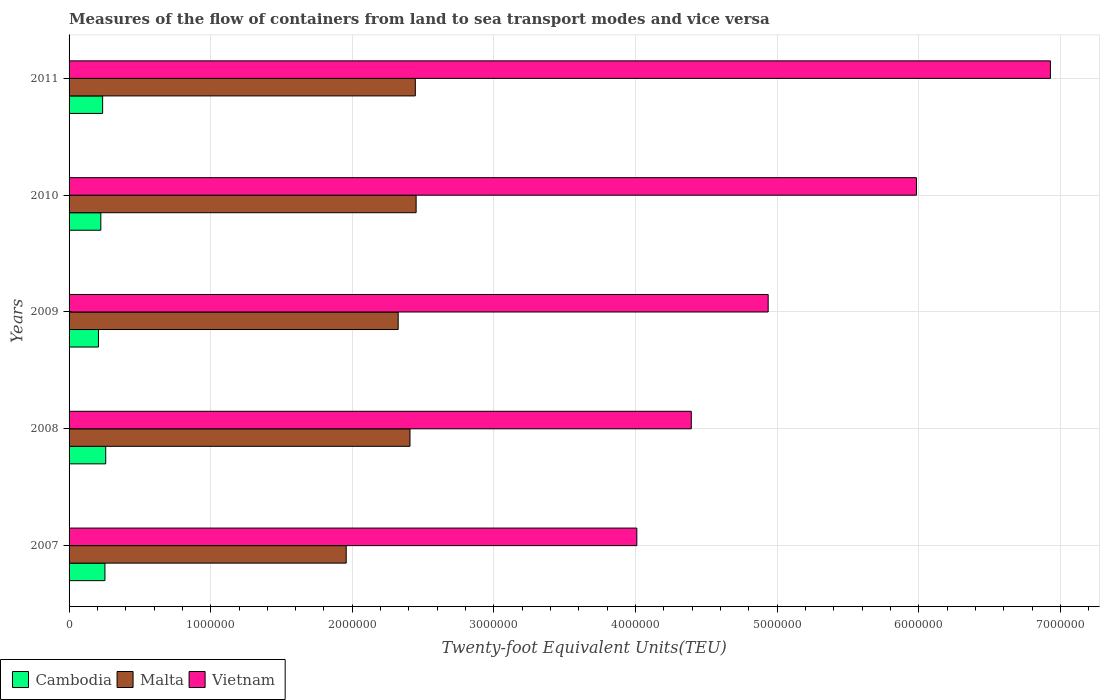How many different coloured bars are there?
Your answer should be very brief. 3. Are the number of bars per tick equal to the number of legend labels?
Keep it short and to the point. Yes. In how many cases, is the number of bars for a given year not equal to the number of legend labels?
Keep it short and to the point. 0. What is the container port traffic in Cambodia in 2008?
Provide a succinct answer. 2.59e+05. Across all years, what is the maximum container port traffic in Malta?
Offer a very short reply. 2.45e+06. Across all years, what is the minimum container port traffic in Cambodia?
Offer a terse response. 2.08e+05. In which year was the container port traffic in Cambodia maximum?
Your answer should be compact. 2008. In which year was the container port traffic in Vietnam minimum?
Offer a very short reply. 2007. What is the total container port traffic in Malta in the graph?
Keep it short and to the point. 1.16e+07. What is the difference between the container port traffic in Cambodia in 2008 and that in 2009?
Ensure brevity in your answer.  5.12e+04. What is the difference between the container port traffic in Cambodia in 2011 and the container port traffic in Vietnam in 2007?
Your answer should be compact. -3.77e+06. What is the average container port traffic in Vietnam per year?
Your response must be concise. 5.25e+06. In the year 2009, what is the difference between the container port traffic in Cambodia and container port traffic in Malta?
Offer a very short reply. -2.12e+06. What is the ratio of the container port traffic in Vietnam in 2010 to that in 2011?
Keep it short and to the point. 0.86. Is the container port traffic in Cambodia in 2008 less than that in 2009?
Your answer should be compact. No. What is the difference between the highest and the second highest container port traffic in Malta?
Your answer should be compact. 5683.65. What is the difference between the highest and the lowest container port traffic in Cambodia?
Offer a very short reply. 5.12e+04. In how many years, is the container port traffic in Malta greater than the average container port traffic in Malta taken over all years?
Make the answer very short. 4. What does the 2nd bar from the top in 2007 represents?
Keep it short and to the point. Malta. What does the 1st bar from the bottom in 2009 represents?
Your answer should be compact. Cambodia. How many bars are there?
Your answer should be very brief. 15. Are all the bars in the graph horizontal?
Ensure brevity in your answer.  Yes. Are the values on the major ticks of X-axis written in scientific E-notation?
Provide a short and direct response. No. Does the graph contain any zero values?
Ensure brevity in your answer.  No. Does the graph contain grids?
Ensure brevity in your answer.  Yes. Where does the legend appear in the graph?
Your answer should be compact. Bottom left. How many legend labels are there?
Your answer should be very brief. 3. What is the title of the graph?
Your answer should be very brief. Measures of the flow of containers from land to sea transport modes and vice versa. What is the label or title of the X-axis?
Keep it short and to the point. Twenty-foot Equivalent Units(TEU). What is the label or title of the Y-axis?
Provide a short and direct response. Years. What is the Twenty-foot Equivalent Units(TEU) of Cambodia in 2007?
Make the answer very short. 2.53e+05. What is the Twenty-foot Equivalent Units(TEU) in Malta in 2007?
Your response must be concise. 1.96e+06. What is the Twenty-foot Equivalent Units(TEU) in Vietnam in 2007?
Your answer should be very brief. 4.01e+06. What is the Twenty-foot Equivalent Units(TEU) of Cambodia in 2008?
Provide a short and direct response. 2.59e+05. What is the Twenty-foot Equivalent Units(TEU) of Malta in 2008?
Offer a very short reply. 2.41e+06. What is the Twenty-foot Equivalent Units(TEU) in Vietnam in 2008?
Offer a terse response. 4.39e+06. What is the Twenty-foot Equivalent Units(TEU) in Cambodia in 2009?
Offer a very short reply. 2.08e+05. What is the Twenty-foot Equivalent Units(TEU) in Malta in 2009?
Your response must be concise. 2.32e+06. What is the Twenty-foot Equivalent Units(TEU) in Vietnam in 2009?
Provide a succinct answer. 4.94e+06. What is the Twenty-foot Equivalent Units(TEU) in Cambodia in 2010?
Make the answer very short. 2.24e+05. What is the Twenty-foot Equivalent Units(TEU) in Malta in 2010?
Make the answer very short. 2.45e+06. What is the Twenty-foot Equivalent Units(TEU) in Vietnam in 2010?
Offer a very short reply. 5.98e+06. What is the Twenty-foot Equivalent Units(TEU) of Cambodia in 2011?
Provide a succinct answer. 2.37e+05. What is the Twenty-foot Equivalent Units(TEU) in Malta in 2011?
Your response must be concise. 2.44e+06. What is the Twenty-foot Equivalent Units(TEU) in Vietnam in 2011?
Provide a succinct answer. 6.93e+06. Across all years, what is the maximum Twenty-foot Equivalent Units(TEU) in Cambodia?
Give a very brief answer. 2.59e+05. Across all years, what is the maximum Twenty-foot Equivalent Units(TEU) of Malta?
Make the answer very short. 2.45e+06. Across all years, what is the maximum Twenty-foot Equivalent Units(TEU) of Vietnam?
Your answer should be very brief. 6.93e+06. Across all years, what is the minimum Twenty-foot Equivalent Units(TEU) of Cambodia?
Offer a very short reply. 2.08e+05. Across all years, what is the minimum Twenty-foot Equivalent Units(TEU) in Malta?
Keep it short and to the point. 1.96e+06. Across all years, what is the minimum Twenty-foot Equivalent Units(TEU) of Vietnam?
Your answer should be compact. 4.01e+06. What is the total Twenty-foot Equivalent Units(TEU) in Cambodia in the graph?
Offer a very short reply. 1.18e+06. What is the total Twenty-foot Equivalent Units(TEU) in Malta in the graph?
Your answer should be compact. 1.16e+07. What is the total Twenty-foot Equivalent Units(TEU) of Vietnam in the graph?
Offer a very short reply. 2.63e+07. What is the difference between the Twenty-foot Equivalent Units(TEU) of Cambodia in 2007 and that in 2008?
Offer a very short reply. -5504. What is the difference between the Twenty-foot Equivalent Units(TEU) of Malta in 2007 and that in 2008?
Your answer should be compact. -4.50e+05. What is the difference between the Twenty-foot Equivalent Units(TEU) of Vietnam in 2007 and that in 2008?
Offer a terse response. -3.85e+05. What is the difference between the Twenty-foot Equivalent Units(TEU) of Cambodia in 2007 and that in 2009?
Ensure brevity in your answer.  4.57e+04. What is the difference between the Twenty-foot Equivalent Units(TEU) of Malta in 2007 and that in 2009?
Give a very brief answer. -3.67e+05. What is the difference between the Twenty-foot Equivalent Units(TEU) of Vietnam in 2007 and that in 2009?
Give a very brief answer. -9.28e+05. What is the difference between the Twenty-foot Equivalent Units(TEU) in Cambodia in 2007 and that in 2010?
Keep it short and to the point. 2.91e+04. What is the difference between the Twenty-foot Equivalent Units(TEU) in Malta in 2007 and that in 2010?
Offer a terse response. -4.94e+05. What is the difference between the Twenty-foot Equivalent Units(TEU) of Vietnam in 2007 and that in 2010?
Provide a short and direct response. -1.97e+06. What is the difference between the Twenty-foot Equivalent Units(TEU) of Cambodia in 2007 and that in 2011?
Make the answer very short. 1.63e+04. What is the difference between the Twenty-foot Equivalent Units(TEU) in Malta in 2007 and that in 2011?
Keep it short and to the point. -4.88e+05. What is the difference between the Twenty-foot Equivalent Units(TEU) in Vietnam in 2007 and that in 2011?
Ensure brevity in your answer.  -2.92e+06. What is the difference between the Twenty-foot Equivalent Units(TEU) of Cambodia in 2008 and that in 2009?
Provide a succinct answer. 5.12e+04. What is the difference between the Twenty-foot Equivalent Units(TEU) of Malta in 2008 and that in 2009?
Provide a succinct answer. 8.34e+04. What is the difference between the Twenty-foot Equivalent Units(TEU) of Vietnam in 2008 and that in 2009?
Make the answer very short. -5.43e+05. What is the difference between the Twenty-foot Equivalent Units(TEU) of Cambodia in 2008 and that in 2010?
Provide a succinct answer. 3.46e+04. What is the difference between the Twenty-foot Equivalent Units(TEU) in Malta in 2008 and that in 2010?
Provide a succinct answer. -4.33e+04. What is the difference between the Twenty-foot Equivalent Units(TEU) in Vietnam in 2008 and that in 2010?
Your response must be concise. -1.59e+06. What is the difference between the Twenty-foot Equivalent Units(TEU) of Cambodia in 2008 and that in 2011?
Your response must be concise. 2.18e+04. What is the difference between the Twenty-foot Equivalent Units(TEU) of Malta in 2008 and that in 2011?
Provide a succinct answer. -3.76e+04. What is the difference between the Twenty-foot Equivalent Units(TEU) in Vietnam in 2008 and that in 2011?
Provide a short and direct response. -2.54e+06. What is the difference between the Twenty-foot Equivalent Units(TEU) in Cambodia in 2009 and that in 2010?
Offer a terse response. -1.66e+04. What is the difference between the Twenty-foot Equivalent Units(TEU) of Malta in 2009 and that in 2010?
Provide a short and direct response. -1.27e+05. What is the difference between the Twenty-foot Equivalent Units(TEU) of Vietnam in 2009 and that in 2010?
Your answer should be very brief. -1.05e+06. What is the difference between the Twenty-foot Equivalent Units(TEU) of Cambodia in 2009 and that in 2011?
Your response must be concise. -2.94e+04. What is the difference between the Twenty-foot Equivalent Units(TEU) of Malta in 2009 and that in 2011?
Keep it short and to the point. -1.21e+05. What is the difference between the Twenty-foot Equivalent Units(TEU) of Vietnam in 2009 and that in 2011?
Your answer should be compact. -1.99e+06. What is the difference between the Twenty-foot Equivalent Units(TEU) in Cambodia in 2010 and that in 2011?
Give a very brief answer. -1.28e+04. What is the difference between the Twenty-foot Equivalent Units(TEU) of Malta in 2010 and that in 2011?
Give a very brief answer. 5683.65. What is the difference between the Twenty-foot Equivalent Units(TEU) of Vietnam in 2010 and that in 2011?
Give a very brief answer. -9.46e+05. What is the difference between the Twenty-foot Equivalent Units(TEU) of Cambodia in 2007 and the Twenty-foot Equivalent Units(TEU) of Malta in 2008?
Make the answer very short. -2.15e+06. What is the difference between the Twenty-foot Equivalent Units(TEU) in Cambodia in 2007 and the Twenty-foot Equivalent Units(TEU) in Vietnam in 2008?
Make the answer very short. -4.14e+06. What is the difference between the Twenty-foot Equivalent Units(TEU) in Malta in 2007 and the Twenty-foot Equivalent Units(TEU) in Vietnam in 2008?
Your response must be concise. -2.44e+06. What is the difference between the Twenty-foot Equivalent Units(TEU) of Cambodia in 2007 and the Twenty-foot Equivalent Units(TEU) of Malta in 2009?
Your answer should be very brief. -2.07e+06. What is the difference between the Twenty-foot Equivalent Units(TEU) in Cambodia in 2007 and the Twenty-foot Equivalent Units(TEU) in Vietnam in 2009?
Your answer should be compact. -4.68e+06. What is the difference between the Twenty-foot Equivalent Units(TEU) in Malta in 2007 and the Twenty-foot Equivalent Units(TEU) in Vietnam in 2009?
Keep it short and to the point. -2.98e+06. What is the difference between the Twenty-foot Equivalent Units(TEU) of Cambodia in 2007 and the Twenty-foot Equivalent Units(TEU) of Malta in 2010?
Make the answer very short. -2.20e+06. What is the difference between the Twenty-foot Equivalent Units(TEU) of Cambodia in 2007 and the Twenty-foot Equivalent Units(TEU) of Vietnam in 2010?
Make the answer very short. -5.73e+06. What is the difference between the Twenty-foot Equivalent Units(TEU) in Malta in 2007 and the Twenty-foot Equivalent Units(TEU) in Vietnam in 2010?
Provide a short and direct response. -4.03e+06. What is the difference between the Twenty-foot Equivalent Units(TEU) in Cambodia in 2007 and the Twenty-foot Equivalent Units(TEU) in Malta in 2011?
Your answer should be compact. -2.19e+06. What is the difference between the Twenty-foot Equivalent Units(TEU) in Cambodia in 2007 and the Twenty-foot Equivalent Units(TEU) in Vietnam in 2011?
Provide a succinct answer. -6.68e+06. What is the difference between the Twenty-foot Equivalent Units(TEU) of Malta in 2007 and the Twenty-foot Equivalent Units(TEU) of Vietnam in 2011?
Make the answer very short. -4.97e+06. What is the difference between the Twenty-foot Equivalent Units(TEU) of Cambodia in 2008 and the Twenty-foot Equivalent Units(TEU) of Malta in 2009?
Offer a very short reply. -2.07e+06. What is the difference between the Twenty-foot Equivalent Units(TEU) of Cambodia in 2008 and the Twenty-foot Equivalent Units(TEU) of Vietnam in 2009?
Provide a succinct answer. -4.68e+06. What is the difference between the Twenty-foot Equivalent Units(TEU) in Malta in 2008 and the Twenty-foot Equivalent Units(TEU) in Vietnam in 2009?
Make the answer very short. -2.53e+06. What is the difference between the Twenty-foot Equivalent Units(TEU) in Cambodia in 2008 and the Twenty-foot Equivalent Units(TEU) in Malta in 2010?
Offer a terse response. -2.19e+06. What is the difference between the Twenty-foot Equivalent Units(TEU) in Cambodia in 2008 and the Twenty-foot Equivalent Units(TEU) in Vietnam in 2010?
Your response must be concise. -5.72e+06. What is the difference between the Twenty-foot Equivalent Units(TEU) in Malta in 2008 and the Twenty-foot Equivalent Units(TEU) in Vietnam in 2010?
Offer a very short reply. -3.58e+06. What is the difference between the Twenty-foot Equivalent Units(TEU) of Cambodia in 2008 and the Twenty-foot Equivalent Units(TEU) of Malta in 2011?
Offer a terse response. -2.19e+06. What is the difference between the Twenty-foot Equivalent Units(TEU) of Cambodia in 2008 and the Twenty-foot Equivalent Units(TEU) of Vietnam in 2011?
Offer a very short reply. -6.67e+06. What is the difference between the Twenty-foot Equivalent Units(TEU) in Malta in 2008 and the Twenty-foot Equivalent Units(TEU) in Vietnam in 2011?
Your answer should be very brief. -4.52e+06. What is the difference between the Twenty-foot Equivalent Units(TEU) of Cambodia in 2009 and the Twenty-foot Equivalent Units(TEU) of Malta in 2010?
Your answer should be very brief. -2.24e+06. What is the difference between the Twenty-foot Equivalent Units(TEU) in Cambodia in 2009 and the Twenty-foot Equivalent Units(TEU) in Vietnam in 2010?
Your answer should be very brief. -5.78e+06. What is the difference between the Twenty-foot Equivalent Units(TEU) of Malta in 2009 and the Twenty-foot Equivalent Units(TEU) of Vietnam in 2010?
Your answer should be very brief. -3.66e+06. What is the difference between the Twenty-foot Equivalent Units(TEU) in Cambodia in 2009 and the Twenty-foot Equivalent Units(TEU) in Malta in 2011?
Your answer should be compact. -2.24e+06. What is the difference between the Twenty-foot Equivalent Units(TEU) of Cambodia in 2009 and the Twenty-foot Equivalent Units(TEU) of Vietnam in 2011?
Provide a succinct answer. -6.72e+06. What is the difference between the Twenty-foot Equivalent Units(TEU) in Malta in 2009 and the Twenty-foot Equivalent Units(TEU) in Vietnam in 2011?
Provide a short and direct response. -4.61e+06. What is the difference between the Twenty-foot Equivalent Units(TEU) of Cambodia in 2010 and the Twenty-foot Equivalent Units(TEU) of Malta in 2011?
Keep it short and to the point. -2.22e+06. What is the difference between the Twenty-foot Equivalent Units(TEU) in Cambodia in 2010 and the Twenty-foot Equivalent Units(TEU) in Vietnam in 2011?
Provide a succinct answer. -6.71e+06. What is the difference between the Twenty-foot Equivalent Units(TEU) of Malta in 2010 and the Twenty-foot Equivalent Units(TEU) of Vietnam in 2011?
Give a very brief answer. -4.48e+06. What is the average Twenty-foot Equivalent Units(TEU) of Cambodia per year?
Make the answer very short. 2.36e+05. What is the average Twenty-foot Equivalent Units(TEU) in Malta per year?
Provide a succinct answer. 2.32e+06. What is the average Twenty-foot Equivalent Units(TEU) in Vietnam per year?
Offer a terse response. 5.25e+06. In the year 2007, what is the difference between the Twenty-foot Equivalent Units(TEU) of Cambodia and Twenty-foot Equivalent Units(TEU) of Malta?
Offer a terse response. -1.70e+06. In the year 2007, what is the difference between the Twenty-foot Equivalent Units(TEU) of Cambodia and Twenty-foot Equivalent Units(TEU) of Vietnam?
Ensure brevity in your answer.  -3.76e+06. In the year 2007, what is the difference between the Twenty-foot Equivalent Units(TEU) in Malta and Twenty-foot Equivalent Units(TEU) in Vietnam?
Offer a very short reply. -2.05e+06. In the year 2008, what is the difference between the Twenty-foot Equivalent Units(TEU) of Cambodia and Twenty-foot Equivalent Units(TEU) of Malta?
Make the answer very short. -2.15e+06. In the year 2008, what is the difference between the Twenty-foot Equivalent Units(TEU) of Cambodia and Twenty-foot Equivalent Units(TEU) of Vietnam?
Provide a short and direct response. -4.13e+06. In the year 2008, what is the difference between the Twenty-foot Equivalent Units(TEU) in Malta and Twenty-foot Equivalent Units(TEU) in Vietnam?
Provide a succinct answer. -1.99e+06. In the year 2009, what is the difference between the Twenty-foot Equivalent Units(TEU) in Cambodia and Twenty-foot Equivalent Units(TEU) in Malta?
Provide a short and direct response. -2.12e+06. In the year 2009, what is the difference between the Twenty-foot Equivalent Units(TEU) of Cambodia and Twenty-foot Equivalent Units(TEU) of Vietnam?
Provide a succinct answer. -4.73e+06. In the year 2009, what is the difference between the Twenty-foot Equivalent Units(TEU) in Malta and Twenty-foot Equivalent Units(TEU) in Vietnam?
Your answer should be very brief. -2.61e+06. In the year 2010, what is the difference between the Twenty-foot Equivalent Units(TEU) in Cambodia and Twenty-foot Equivalent Units(TEU) in Malta?
Ensure brevity in your answer.  -2.23e+06. In the year 2010, what is the difference between the Twenty-foot Equivalent Units(TEU) in Cambodia and Twenty-foot Equivalent Units(TEU) in Vietnam?
Keep it short and to the point. -5.76e+06. In the year 2010, what is the difference between the Twenty-foot Equivalent Units(TEU) in Malta and Twenty-foot Equivalent Units(TEU) in Vietnam?
Ensure brevity in your answer.  -3.53e+06. In the year 2011, what is the difference between the Twenty-foot Equivalent Units(TEU) in Cambodia and Twenty-foot Equivalent Units(TEU) in Malta?
Offer a very short reply. -2.21e+06. In the year 2011, what is the difference between the Twenty-foot Equivalent Units(TEU) in Cambodia and Twenty-foot Equivalent Units(TEU) in Vietnam?
Give a very brief answer. -6.69e+06. In the year 2011, what is the difference between the Twenty-foot Equivalent Units(TEU) of Malta and Twenty-foot Equivalent Units(TEU) of Vietnam?
Your answer should be very brief. -4.48e+06. What is the ratio of the Twenty-foot Equivalent Units(TEU) of Cambodia in 2007 to that in 2008?
Offer a very short reply. 0.98. What is the ratio of the Twenty-foot Equivalent Units(TEU) in Malta in 2007 to that in 2008?
Make the answer very short. 0.81. What is the ratio of the Twenty-foot Equivalent Units(TEU) of Vietnam in 2007 to that in 2008?
Offer a very short reply. 0.91. What is the ratio of the Twenty-foot Equivalent Units(TEU) in Cambodia in 2007 to that in 2009?
Offer a terse response. 1.22. What is the ratio of the Twenty-foot Equivalent Units(TEU) of Malta in 2007 to that in 2009?
Your answer should be very brief. 0.84. What is the ratio of the Twenty-foot Equivalent Units(TEU) of Vietnam in 2007 to that in 2009?
Provide a succinct answer. 0.81. What is the ratio of the Twenty-foot Equivalent Units(TEU) in Cambodia in 2007 to that in 2010?
Make the answer very short. 1.13. What is the ratio of the Twenty-foot Equivalent Units(TEU) of Malta in 2007 to that in 2010?
Give a very brief answer. 0.8. What is the ratio of the Twenty-foot Equivalent Units(TEU) in Vietnam in 2007 to that in 2010?
Give a very brief answer. 0.67. What is the ratio of the Twenty-foot Equivalent Units(TEU) of Cambodia in 2007 to that in 2011?
Your response must be concise. 1.07. What is the ratio of the Twenty-foot Equivalent Units(TEU) of Malta in 2007 to that in 2011?
Make the answer very short. 0.8. What is the ratio of the Twenty-foot Equivalent Units(TEU) in Vietnam in 2007 to that in 2011?
Give a very brief answer. 0.58. What is the ratio of the Twenty-foot Equivalent Units(TEU) in Cambodia in 2008 to that in 2009?
Your response must be concise. 1.25. What is the ratio of the Twenty-foot Equivalent Units(TEU) of Malta in 2008 to that in 2009?
Make the answer very short. 1.04. What is the ratio of the Twenty-foot Equivalent Units(TEU) of Vietnam in 2008 to that in 2009?
Your response must be concise. 0.89. What is the ratio of the Twenty-foot Equivalent Units(TEU) in Cambodia in 2008 to that in 2010?
Give a very brief answer. 1.15. What is the ratio of the Twenty-foot Equivalent Units(TEU) in Malta in 2008 to that in 2010?
Offer a terse response. 0.98. What is the ratio of the Twenty-foot Equivalent Units(TEU) in Vietnam in 2008 to that in 2010?
Your response must be concise. 0.73. What is the ratio of the Twenty-foot Equivalent Units(TEU) of Cambodia in 2008 to that in 2011?
Give a very brief answer. 1.09. What is the ratio of the Twenty-foot Equivalent Units(TEU) in Malta in 2008 to that in 2011?
Offer a terse response. 0.98. What is the ratio of the Twenty-foot Equivalent Units(TEU) in Vietnam in 2008 to that in 2011?
Provide a succinct answer. 0.63. What is the ratio of the Twenty-foot Equivalent Units(TEU) of Cambodia in 2009 to that in 2010?
Give a very brief answer. 0.93. What is the ratio of the Twenty-foot Equivalent Units(TEU) of Malta in 2009 to that in 2010?
Your response must be concise. 0.95. What is the ratio of the Twenty-foot Equivalent Units(TEU) in Vietnam in 2009 to that in 2010?
Make the answer very short. 0.82. What is the ratio of the Twenty-foot Equivalent Units(TEU) in Cambodia in 2009 to that in 2011?
Provide a short and direct response. 0.88. What is the ratio of the Twenty-foot Equivalent Units(TEU) of Malta in 2009 to that in 2011?
Offer a very short reply. 0.95. What is the ratio of the Twenty-foot Equivalent Units(TEU) in Vietnam in 2009 to that in 2011?
Your answer should be very brief. 0.71. What is the ratio of the Twenty-foot Equivalent Units(TEU) of Cambodia in 2010 to that in 2011?
Provide a succinct answer. 0.95. What is the ratio of the Twenty-foot Equivalent Units(TEU) of Vietnam in 2010 to that in 2011?
Make the answer very short. 0.86. What is the difference between the highest and the second highest Twenty-foot Equivalent Units(TEU) of Cambodia?
Provide a short and direct response. 5504. What is the difference between the highest and the second highest Twenty-foot Equivalent Units(TEU) of Malta?
Keep it short and to the point. 5683.65. What is the difference between the highest and the second highest Twenty-foot Equivalent Units(TEU) of Vietnam?
Make the answer very short. 9.46e+05. What is the difference between the highest and the lowest Twenty-foot Equivalent Units(TEU) of Cambodia?
Offer a terse response. 5.12e+04. What is the difference between the highest and the lowest Twenty-foot Equivalent Units(TEU) of Malta?
Keep it short and to the point. 4.94e+05. What is the difference between the highest and the lowest Twenty-foot Equivalent Units(TEU) in Vietnam?
Your answer should be very brief. 2.92e+06. 